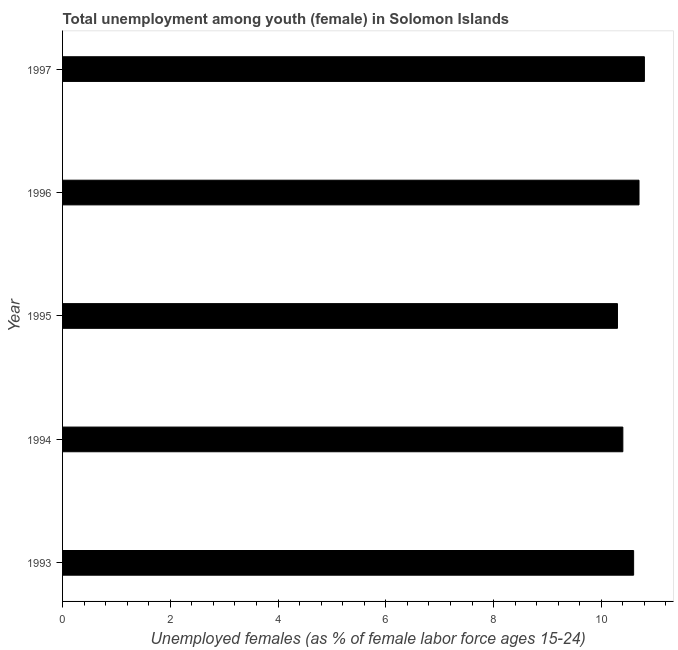What is the title of the graph?
Your answer should be very brief. Total unemployment among youth (female) in Solomon Islands. What is the label or title of the X-axis?
Offer a terse response. Unemployed females (as % of female labor force ages 15-24). What is the unemployed female youth population in 1993?
Your answer should be compact. 10.6. Across all years, what is the maximum unemployed female youth population?
Offer a very short reply. 10.8. Across all years, what is the minimum unemployed female youth population?
Make the answer very short. 10.3. What is the sum of the unemployed female youth population?
Offer a very short reply. 52.8. What is the average unemployed female youth population per year?
Provide a succinct answer. 10.56. What is the median unemployed female youth population?
Offer a terse response. 10.6. Do a majority of the years between 1993 and 1996 (inclusive) have unemployed female youth population greater than 5.2 %?
Offer a very short reply. Yes. What is the ratio of the unemployed female youth population in 1993 to that in 1995?
Give a very brief answer. 1.03. Is the unemployed female youth population in 1993 less than that in 1995?
Keep it short and to the point. No. What is the difference between the highest and the second highest unemployed female youth population?
Provide a short and direct response. 0.1. Is the sum of the unemployed female youth population in 1993 and 1997 greater than the maximum unemployed female youth population across all years?
Give a very brief answer. Yes. In how many years, is the unemployed female youth population greater than the average unemployed female youth population taken over all years?
Make the answer very short. 3. How many bars are there?
Your answer should be compact. 5. Are all the bars in the graph horizontal?
Offer a terse response. Yes. How many years are there in the graph?
Offer a terse response. 5. What is the Unemployed females (as % of female labor force ages 15-24) of 1993?
Offer a very short reply. 10.6. What is the Unemployed females (as % of female labor force ages 15-24) of 1994?
Provide a short and direct response. 10.4. What is the Unemployed females (as % of female labor force ages 15-24) of 1995?
Your answer should be very brief. 10.3. What is the Unemployed females (as % of female labor force ages 15-24) in 1996?
Offer a terse response. 10.7. What is the Unemployed females (as % of female labor force ages 15-24) of 1997?
Your answer should be very brief. 10.8. What is the difference between the Unemployed females (as % of female labor force ages 15-24) in 1993 and 1995?
Give a very brief answer. 0.3. What is the difference between the Unemployed females (as % of female labor force ages 15-24) in 1993 and 1997?
Provide a short and direct response. -0.2. What is the difference between the Unemployed females (as % of female labor force ages 15-24) in 1996 and 1997?
Ensure brevity in your answer.  -0.1. What is the ratio of the Unemployed females (as % of female labor force ages 15-24) in 1993 to that in 1997?
Your response must be concise. 0.98. What is the ratio of the Unemployed females (as % of female labor force ages 15-24) in 1994 to that in 1995?
Your answer should be very brief. 1.01. What is the ratio of the Unemployed females (as % of female labor force ages 15-24) in 1994 to that in 1997?
Offer a very short reply. 0.96. What is the ratio of the Unemployed females (as % of female labor force ages 15-24) in 1995 to that in 1996?
Make the answer very short. 0.96. What is the ratio of the Unemployed females (as % of female labor force ages 15-24) in 1995 to that in 1997?
Keep it short and to the point. 0.95. 